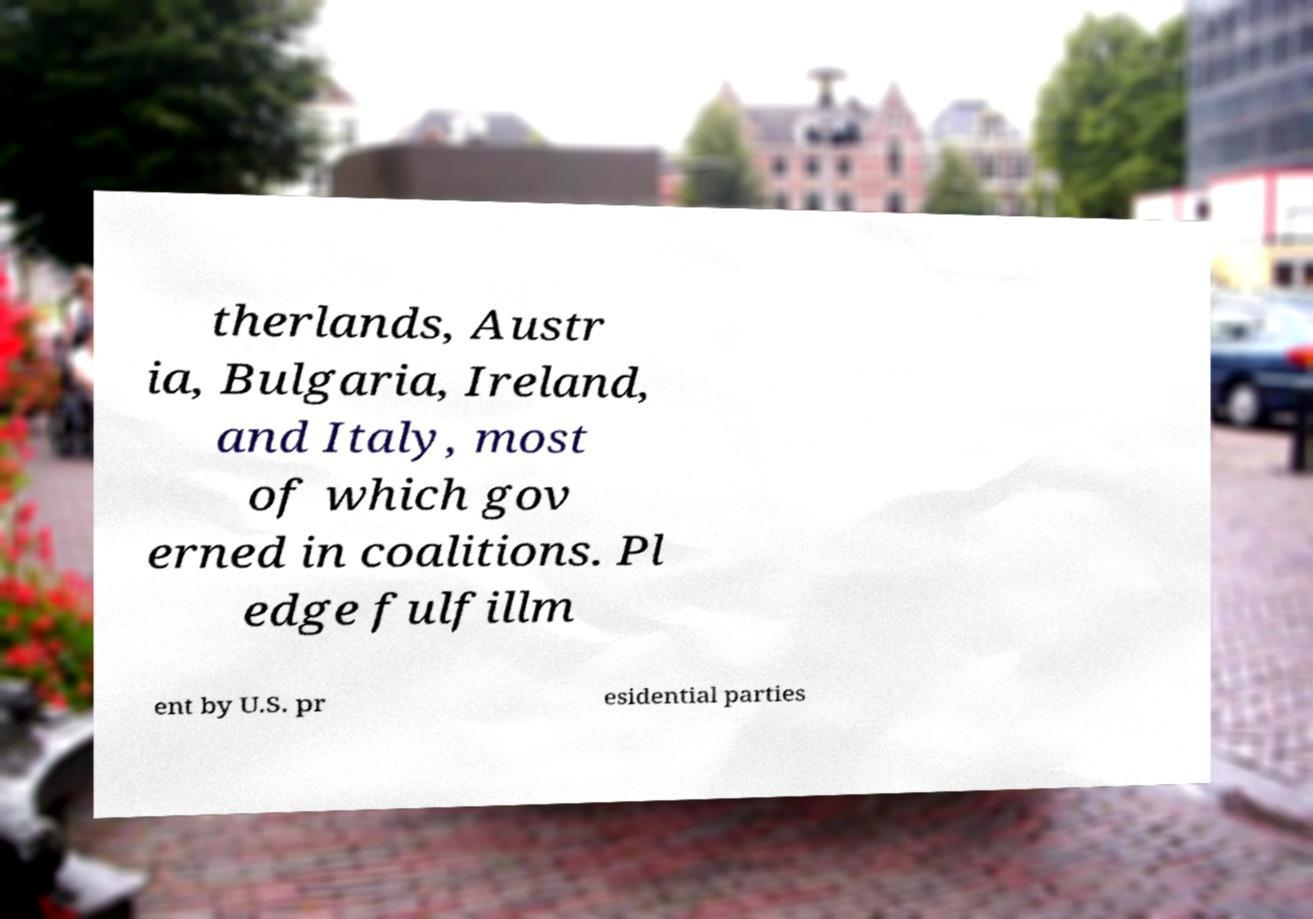What messages or text are displayed in this image? I need them in a readable, typed format. therlands, Austr ia, Bulgaria, Ireland, and Italy, most of which gov erned in coalitions. Pl edge fulfillm ent by U.S. pr esidential parties 